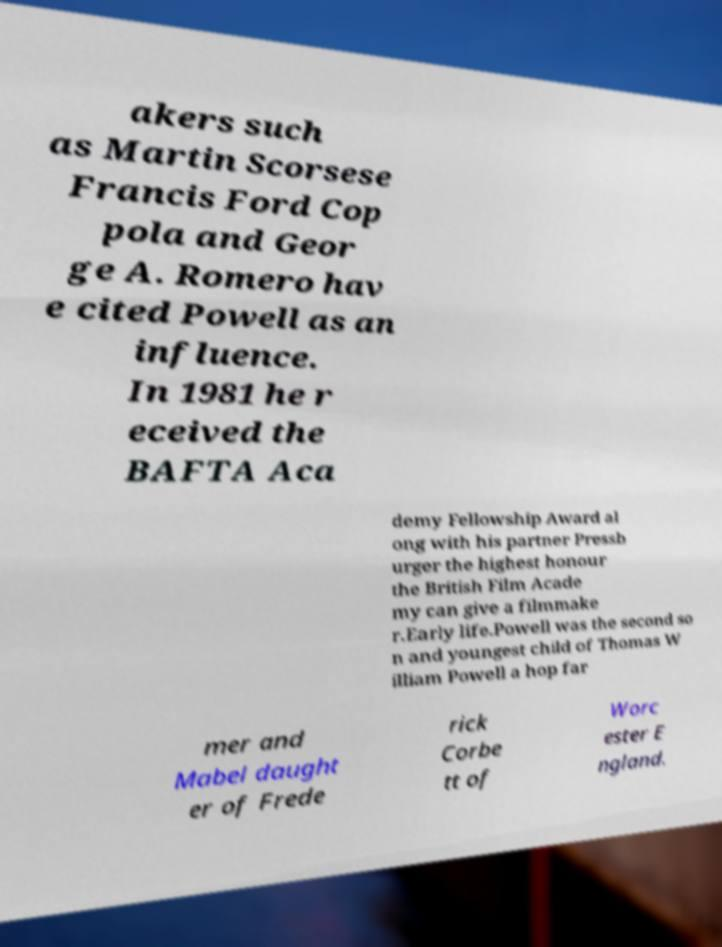I need the written content from this picture converted into text. Can you do that? akers such as Martin Scorsese Francis Ford Cop pola and Geor ge A. Romero hav e cited Powell as an influence. In 1981 he r eceived the BAFTA Aca demy Fellowship Award al ong with his partner Pressb urger the highest honour the British Film Acade my can give a filmmake r.Early life.Powell was the second so n and youngest child of Thomas W illiam Powell a hop far mer and Mabel daught er of Frede rick Corbe tt of Worc ester E ngland. 